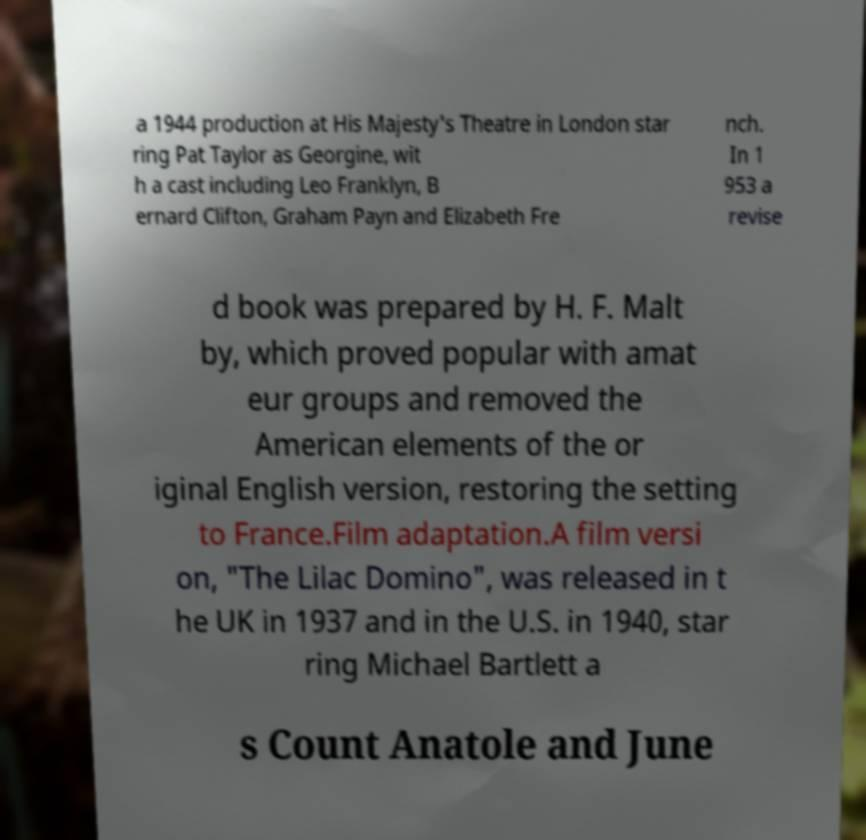Please read and relay the text visible in this image. What does it say? a 1944 production at His Majesty's Theatre in London star ring Pat Taylor as Georgine, wit h a cast including Leo Franklyn, B ernard Clifton, Graham Payn and Elizabeth Fre nch. In 1 953 a revise d book was prepared by H. F. Malt by, which proved popular with amat eur groups and removed the American elements of the or iginal English version, restoring the setting to France.Film adaptation.A film versi on, "The Lilac Domino", was released in t he UK in 1937 and in the U.S. in 1940, star ring Michael Bartlett a s Count Anatole and June 